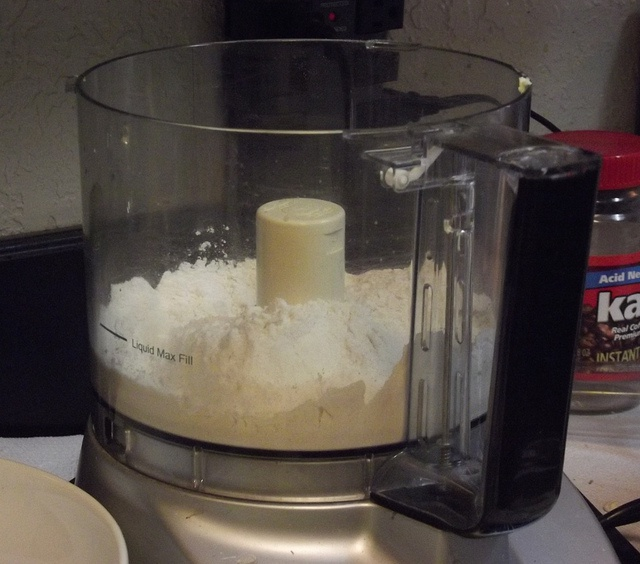Describe the objects in this image and their specific colors. I can see bottle in black, maroon, and gray tones and bowl in black, gray, and darkgray tones in this image. 